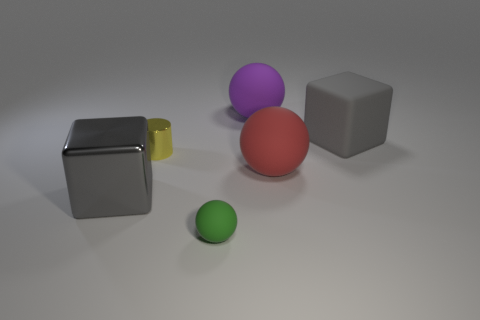Is there a matte thing to the right of the sphere that is behind the big gray block that is right of the small rubber object?
Keep it short and to the point. Yes. There is a tiny object that is the same material as the purple ball; what is its color?
Keep it short and to the point. Green. There is a cube that is on the left side of the big red ball; is its color the same as the big matte cube?
Make the answer very short. Yes. How many cylinders are tiny green things or gray metal objects?
Offer a terse response. 0. What size is the gray block that is behind the big cube in front of the rubber object right of the large red matte object?
Give a very brief answer. Large. There is a yellow metal object that is the same size as the green rubber object; what shape is it?
Make the answer very short. Cylinder. What shape is the big gray metallic object?
Keep it short and to the point. Cube. Are the big gray cube left of the green matte object and the small yellow cylinder made of the same material?
Make the answer very short. Yes. How big is the gray object that is right of the big gray thing left of the large purple ball?
Ensure brevity in your answer.  Large. There is a big object that is in front of the big gray matte cube and on the right side of the tiny green rubber object; what is its color?
Ensure brevity in your answer.  Red. 